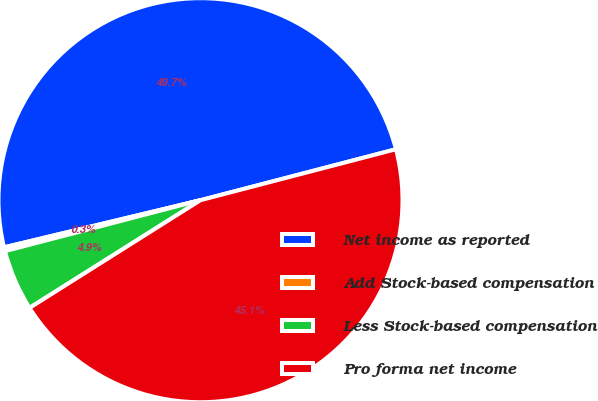<chart> <loc_0><loc_0><loc_500><loc_500><pie_chart><fcel>Net income as reported<fcel>Add Stock-based compensation<fcel>Less Stock-based compensation<fcel>Pro forma net income<nl><fcel>49.69%<fcel>0.31%<fcel>4.89%<fcel>45.11%<nl></chart> 